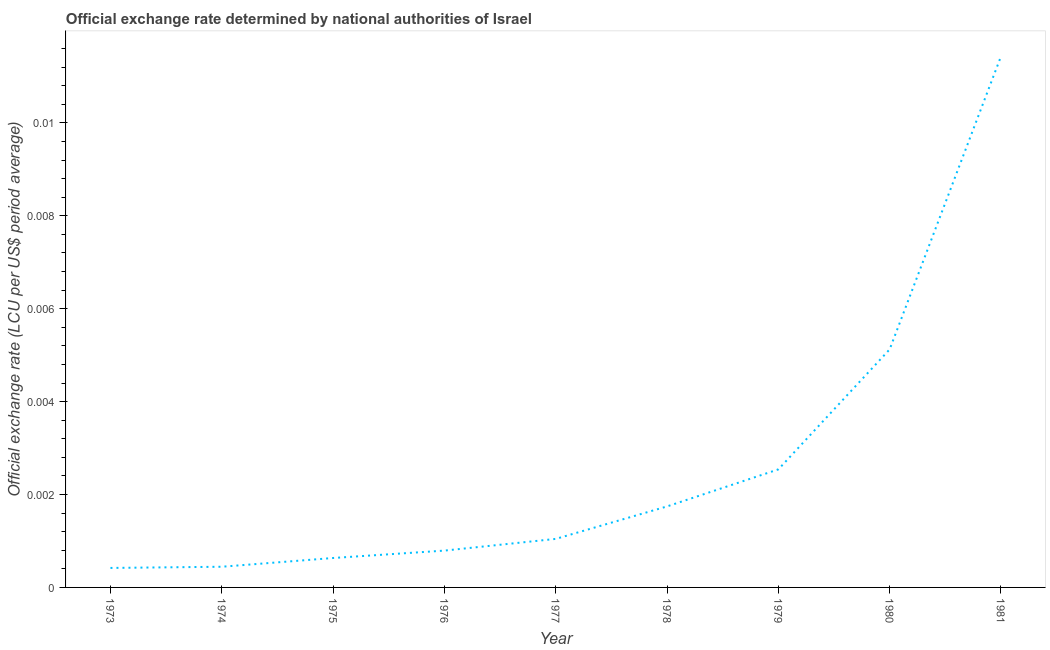What is the official exchange rate in 1976?
Offer a terse response. 0. Across all years, what is the maximum official exchange rate?
Offer a terse response. 0.01. Across all years, what is the minimum official exchange rate?
Your answer should be compact. 0. In which year was the official exchange rate minimum?
Provide a succinct answer. 1973. What is the sum of the official exchange rate?
Ensure brevity in your answer.  0.02. What is the difference between the official exchange rate in 1973 and 1975?
Your answer should be very brief. -0. What is the average official exchange rate per year?
Your response must be concise. 0. What is the median official exchange rate?
Offer a terse response. 0. What is the ratio of the official exchange rate in 1976 to that in 1978?
Offer a terse response. 0.45. Is the official exchange rate in 1973 less than that in 1974?
Provide a succinct answer. Yes. Is the difference between the official exchange rate in 1979 and 1980 greater than the difference between any two years?
Your answer should be very brief. No. What is the difference between the highest and the second highest official exchange rate?
Offer a terse response. 0.01. Is the sum of the official exchange rate in 1975 and 1981 greater than the maximum official exchange rate across all years?
Offer a terse response. Yes. What is the difference between the highest and the lowest official exchange rate?
Your response must be concise. 0.01. How many years are there in the graph?
Ensure brevity in your answer.  9. What is the difference between two consecutive major ticks on the Y-axis?
Your response must be concise. 0. Are the values on the major ticks of Y-axis written in scientific E-notation?
Keep it short and to the point. No. Does the graph contain any zero values?
Keep it short and to the point. No. Does the graph contain grids?
Your answer should be compact. No. What is the title of the graph?
Offer a very short reply. Official exchange rate determined by national authorities of Israel. What is the label or title of the Y-axis?
Ensure brevity in your answer.  Official exchange rate (LCU per US$ period average). What is the Official exchange rate (LCU per US$ period average) of 1973?
Give a very brief answer. 0. What is the Official exchange rate (LCU per US$ period average) of 1974?
Provide a succinct answer. 0. What is the Official exchange rate (LCU per US$ period average) of 1975?
Your response must be concise. 0. What is the Official exchange rate (LCU per US$ period average) of 1976?
Provide a succinct answer. 0. What is the Official exchange rate (LCU per US$ period average) in 1977?
Your response must be concise. 0. What is the Official exchange rate (LCU per US$ period average) in 1978?
Provide a succinct answer. 0. What is the Official exchange rate (LCU per US$ period average) in 1979?
Provide a short and direct response. 0. What is the Official exchange rate (LCU per US$ period average) in 1980?
Your response must be concise. 0.01. What is the Official exchange rate (LCU per US$ period average) in 1981?
Your answer should be compact. 0.01. What is the difference between the Official exchange rate (LCU per US$ period average) in 1973 and 1974?
Your response must be concise. -3e-5. What is the difference between the Official exchange rate (LCU per US$ period average) in 1973 and 1975?
Provide a succinct answer. -0. What is the difference between the Official exchange rate (LCU per US$ period average) in 1973 and 1976?
Make the answer very short. -0. What is the difference between the Official exchange rate (LCU per US$ period average) in 1973 and 1977?
Make the answer very short. -0. What is the difference between the Official exchange rate (LCU per US$ period average) in 1973 and 1978?
Ensure brevity in your answer.  -0. What is the difference between the Official exchange rate (LCU per US$ period average) in 1973 and 1979?
Offer a very short reply. -0. What is the difference between the Official exchange rate (LCU per US$ period average) in 1973 and 1980?
Provide a succinct answer. -0. What is the difference between the Official exchange rate (LCU per US$ period average) in 1973 and 1981?
Provide a short and direct response. -0.01. What is the difference between the Official exchange rate (LCU per US$ period average) in 1974 and 1975?
Your answer should be compact. -0. What is the difference between the Official exchange rate (LCU per US$ period average) in 1974 and 1976?
Provide a succinct answer. -0. What is the difference between the Official exchange rate (LCU per US$ period average) in 1974 and 1977?
Your answer should be compact. -0. What is the difference between the Official exchange rate (LCU per US$ period average) in 1974 and 1978?
Make the answer very short. -0. What is the difference between the Official exchange rate (LCU per US$ period average) in 1974 and 1979?
Offer a very short reply. -0. What is the difference between the Official exchange rate (LCU per US$ period average) in 1974 and 1980?
Your response must be concise. -0. What is the difference between the Official exchange rate (LCU per US$ period average) in 1974 and 1981?
Offer a terse response. -0.01. What is the difference between the Official exchange rate (LCU per US$ period average) in 1975 and 1976?
Provide a succinct answer. -0. What is the difference between the Official exchange rate (LCU per US$ period average) in 1975 and 1977?
Your response must be concise. -0. What is the difference between the Official exchange rate (LCU per US$ period average) in 1975 and 1978?
Offer a terse response. -0. What is the difference between the Official exchange rate (LCU per US$ period average) in 1975 and 1979?
Give a very brief answer. -0. What is the difference between the Official exchange rate (LCU per US$ period average) in 1975 and 1980?
Give a very brief answer. -0. What is the difference between the Official exchange rate (LCU per US$ period average) in 1975 and 1981?
Ensure brevity in your answer.  -0.01. What is the difference between the Official exchange rate (LCU per US$ period average) in 1976 and 1977?
Your response must be concise. -0. What is the difference between the Official exchange rate (LCU per US$ period average) in 1976 and 1978?
Ensure brevity in your answer.  -0. What is the difference between the Official exchange rate (LCU per US$ period average) in 1976 and 1979?
Offer a terse response. -0. What is the difference between the Official exchange rate (LCU per US$ period average) in 1976 and 1980?
Offer a very short reply. -0. What is the difference between the Official exchange rate (LCU per US$ period average) in 1976 and 1981?
Provide a succinct answer. -0.01. What is the difference between the Official exchange rate (LCU per US$ period average) in 1977 and 1978?
Provide a short and direct response. -0. What is the difference between the Official exchange rate (LCU per US$ period average) in 1977 and 1979?
Provide a short and direct response. -0. What is the difference between the Official exchange rate (LCU per US$ period average) in 1977 and 1980?
Provide a short and direct response. -0. What is the difference between the Official exchange rate (LCU per US$ period average) in 1977 and 1981?
Offer a very short reply. -0.01. What is the difference between the Official exchange rate (LCU per US$ period average) in 1978 and 1979?
Your response must be concise. -0. What is the difference between the Official exchange rate (LCU per US$ period average) in 1978 and 1980?
Keep it short and to the point. -0. What is the difference between the Official exchange rate (LCU per US$ period average) in 1978 and 1981?
Offer a very short reply. -0.01. What is the difference between the Official exchange rate (LCU per US$ period average) in 1979 and 1980?
Offer a very short reply. -0. What is the difference between the Official exchange rate (LCU per US$ period average) in 1979 and 1981?
Your response must be concise. -0.01. What is the difference between the Official exchange rate (LCU per US$ period average) in 1980 and 1981?
Your answer should be compact. -0.01. What is the ratio of the Official exchange rate (LCU per US$ period average) in 1973 to that in 1974?
Your response must be concise. 0.94. What is the ratio of the Official exchange rate (LCU per US$ period average) in 1973 to that in 1975?
Ensure brevity in your answer.  0.66. What is the ratio of the Official exchange rate (LCU per US$ period average) in 1973 to that in 1976?
Offer a terse response. 0.53. What is the ratio of the Official exchange rate (LCU per US$ period average) in 1973 to that in 1977?
Your answer should be compact. 0.4. What is the ratio of the Official exchange rate (LCU per US$ period average) in 1973 to that in 1978?
Your answer should be compact. 0.24. What is the ratio of the Official exchange rate (LCU per US$ period average) in 1973 to that in 1979?
Offer a terse response. 0.17. What is the ratio of the Official exchange rate (LCU per US$ period average) in 1973 to that in 1980?
Your response must be concise. 0.08. What is the ratio of the Official exchange rate (LCU per US$ period average) in 1973 to that in 1981?
Provide a short and direct response. 0.04. What is the ratio of the Official exchange rate (LCU per US$ period average) in 1974 to that in 1975?
Give a very brief answer. 0.7. What is the ratio of the Official exchange rate (LCU per US$ period average) in 1974 to that in 1976?
Offer a very short reply. 0.56. What is the ratio of the Official exchange rate (LCU per US$ period average) in 1974 to that in 1977?
Your answer should be compact. 0.43. What is the ratio of the Official exchange rate (LCU per US$ period average) in 1974 to that in 1978?
Ensure brevity in your answer.  0.26. What is the ratio of the Official exchange rate (LCU per US$ period average) in 1974 to that in 1979?
Keep it short and to the point. 0.17. What is the ratio of the Official exchange rate (LCU per US$ period average) in 1974 to that in 1980?
Your answer should be compact. 0.09. What is the ratio of the Official exchange rate (LCU per US$ period average) in 1974 to that in 1981?
Provide a succinct answer. 0.04. What is the ratio of the Official exchange rate (LCU per US$ period average) in 1975 to that in 1976?
Give a very brief answer. 0.8. What is the ratio of the Official exchange rate (LCU per US$ period average) in 1975 to that in 1977?
Your response must be concise. 0.61. What is the ratio of the Official exchange rate (LCU per US$ period average) in 1975 to that in 1978?
Keep it short and to the point. 0.36. What is the ratio of the Official exchange rate (LCU per US$ period average) in 1975 to that in 1979?
Offer a very short reply. 0.25. What is the ratio of the Official exchange rate (LCU per US$ period average) in 1975 to that in 1980?
Offer a very short reply. 0.12. What is the ratio of the Official exchange rate (LCU per US$ period average) in 1975 to that in 1981?
Your answer should be very brief. 0.06. What is the ratio of the Official exchange rate (LCU per US$ period average) in 1976 to that in 1977?
Offer a terse response. 0.76. What is the ratio of the Official exchange rate (LCU per US$ period average) in 1976 to that in 1978?
Your response must be concise. 0.46. What is the ratio of the Official exchange rate (LCU per US$ period average) in 1976 to that in 1979?
Offer a terse response. 0.31. What is the ratio of the Official exchange rate (LCU per US$ period average) in 1976 to that in 1980?
Offer a terse response. 0.15. What is the ratio of the Official exchange rate (LCU per US$ period average) in 1976 to that in 1981?
Your answer should be compact. 0.07. What is the ratio of the Official exchange rate (LCU per US$ period average) in 1977 to that in 1978?
Ensure brevity in your answer.  0.6. What is the ratio of the Official exchange rate (LCU per US$ period average) in 1977 to that in 1979?
Ensure brevity in your answer.  0.41. What is the ratio of the Official exchange rate (LCU per US$ period average) in 1977 to that in 1980?
Offer a very short reply. 0.2. What is the ratio of the Official exchange rate (LCU per US$ period average) in 1977 to that in 1981?
Offer a terse response. 0.09. What is the ratio of the Official exchange rate (LCU per US$ period average) in 1978 to that in 1979?
Make the answer very short. 0.69. What is the ratio of the Official exchange rate (LCU per US$ period average) in 1978 to that in 1980?
Give a very brief answer. 0.34. What is the ratio of the Official exchange rate (LCU per US$ period average) in 1978 to that in 1981?
Your answer should be very brief. 0.15. What is the ratio of the Official exchange rate (LCU per US$ period average) in 1979 to that in 1980?
Your response must be concise. 0.5. What is the ratio of the Official exchange rate (LCU per US$ period average) in 1979 to that in 1981?
Keep it short and to the point. 0.22. What is the ratio of the Official exchange rate (LCU per US$ period average) in 1980 to that in 1981?
Your answer should be very brief. 0.45. 